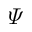Convert formula to latex. <formula><loc_0><loc_0><loc_500><loc_500>\varPsi</formula> 